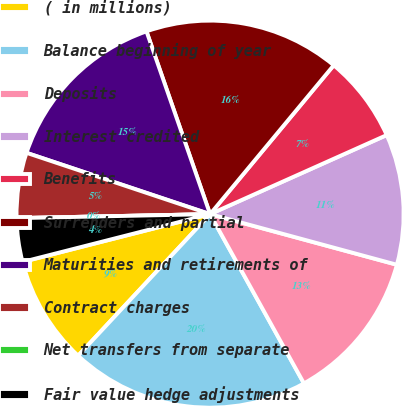Convert chart to OTSL. <chart><loc_0><loc_0><loc_500><loc_500><pie_chart><fcel>( in millions)<fcel>Balance beginning of year<fcel>Deposits<fcel>Interest credited<fcel>Benefits<fcel>Surrenders and partial<fcel>Maturities and retirements of<fcel>Contract charges<fcel>Net transfers from separate<fcel>Fair value hedge adjustments<nl><fcel>9.09%<fcel>20.0%<fcel>12.73%<fcel>10.91%<fcel>7.27%<fcel>16.36%<fcel>14.54%<fcel>5.46%<fcel>0.0%<fcel>3.64%<nl></chart> 